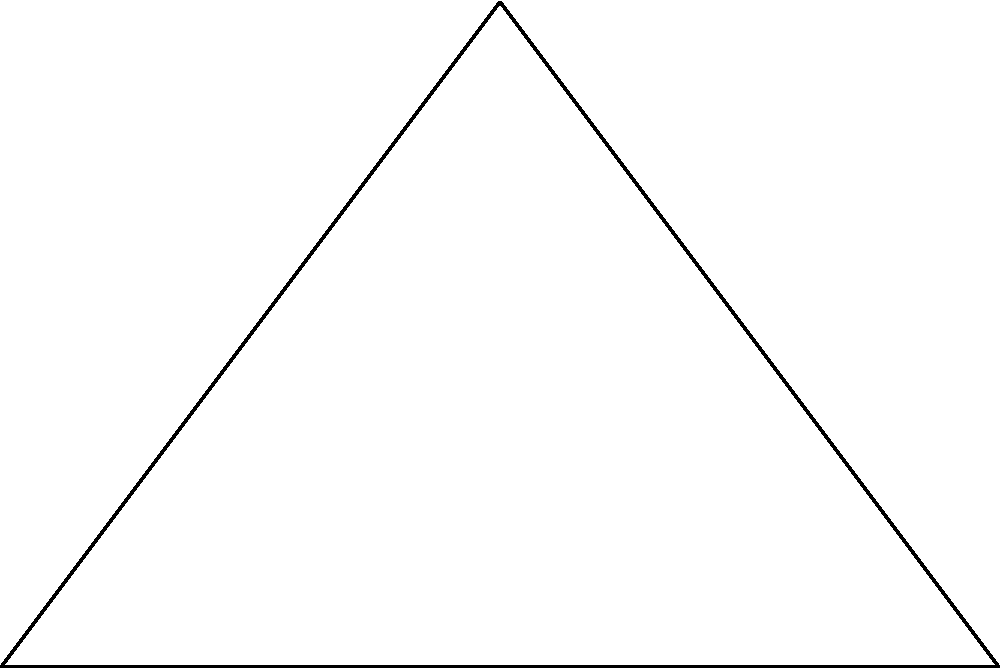In the triangular pediment of an ancient Luxor temple, an inscribed circle perfectly touches all three sides. If the base of the pediment is 6 meters and its height is 4 meters, what is the circumference of the inscribed circle? Let's approach this step-by-step:

1) First, we need to find the radius of the inscribed circle. In a triangle with semi-perimeter $s$ and area $A$, the radius $r$ of the inscribed circle is given by $r = \frac{A}{s}$.

2) To find the area of the triangle:
   $A = \frac{1}{2} \times base \times height = \frac{1}{2} \times 6 \times 4 = 12$ m²

3) To find the semi-perimeter, we need the third side of the triangle. We can find this using the Pythagorean theorem:
   $c^2 = 3^2 + 4^2 = 25$
   $c = 5$ m

4) Now we can calculate the semi-perimeter:
   $s = \frac{6 + 5 + 5}{2} = 8$ m

5) We can now calculate the radius:
   $r = \frac{A}{s} = \frac{12}{8} = 1.5$ m

6) The circumference of a circle is given by the formula $C = 2\pi r$

7) Therefore, the circumference is:
   $C = 2\pi \times 1.5 = 3\pi$ m
Answer: $3\pi$ meters 